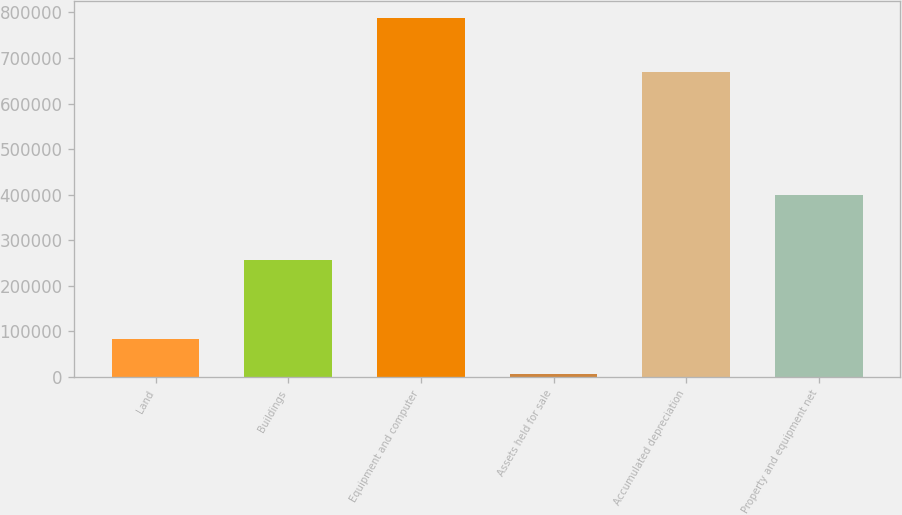Convert chart. <chart><loc_0><loc_0><loc_500><loc_500><bar_chart><fcel>Land<fcel>Buildings<fcel>Equipment and computer<fcel>Assets held for sale<fcel>Accumulated depreciation<fcel>Property and equipment net<nl><fcel>84226.1<fcel>256997<fcel>786713<fcel>6172<fcel>669705<fcel>399506<nl></chart> 